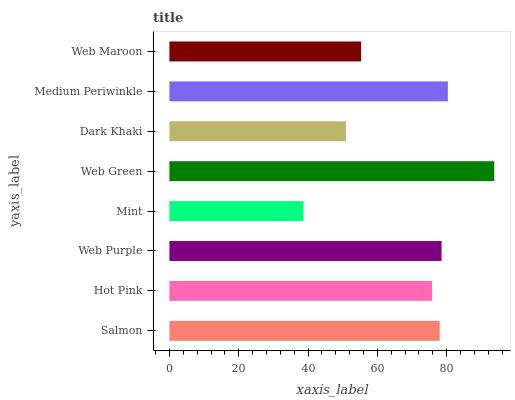Is Mint the minimum?
Answer yes or no. Yes. Is Web Green the maximum?
Answer yes or no. Yes. Is Hot Pink the minimum?
Answer yes or no. No. Is Hot Pink the maximum?
Answer yes or no. No. Is Salmon greater than Hot Pink?
Answer yes or no. Yes. Is Hot Pink less than Salmon?
Answer yes or no. Yes. Is Hot Pink greater than Salmon?
Answer yes or no. No. Is Salmon less than Hot Pink?
Answer yes or no. No. Is Salmon the high median?
Answer yes or no. Yes. Is Hot Pink the low median?
Answer yes or no. Yes. Is Hot Pink the high median?
Answer yes or no. No. Is Mint the low median?
Answer yes or no. No. 